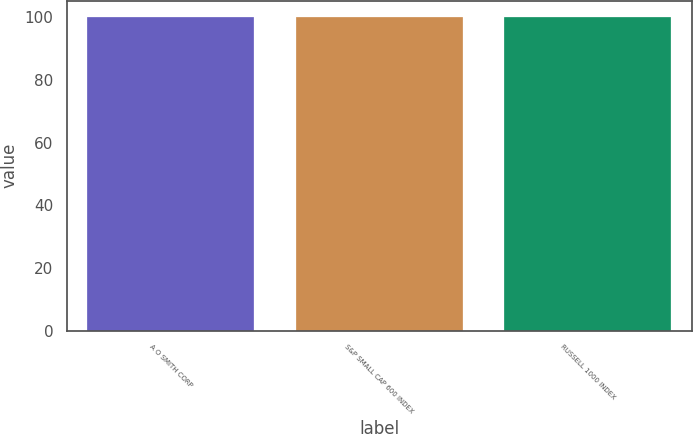Convert chart. <chart><loc_0><loc_0><loc_500><loc_500><bar_chart><fcel>A O SMITH CORP<fcel>S&P SMALL CAP 600 INDEX<fcel>RUSSELL 1000 INDEX<nl><fcel>100<fcel>100.1<fcel>100.2<nl></chart> 